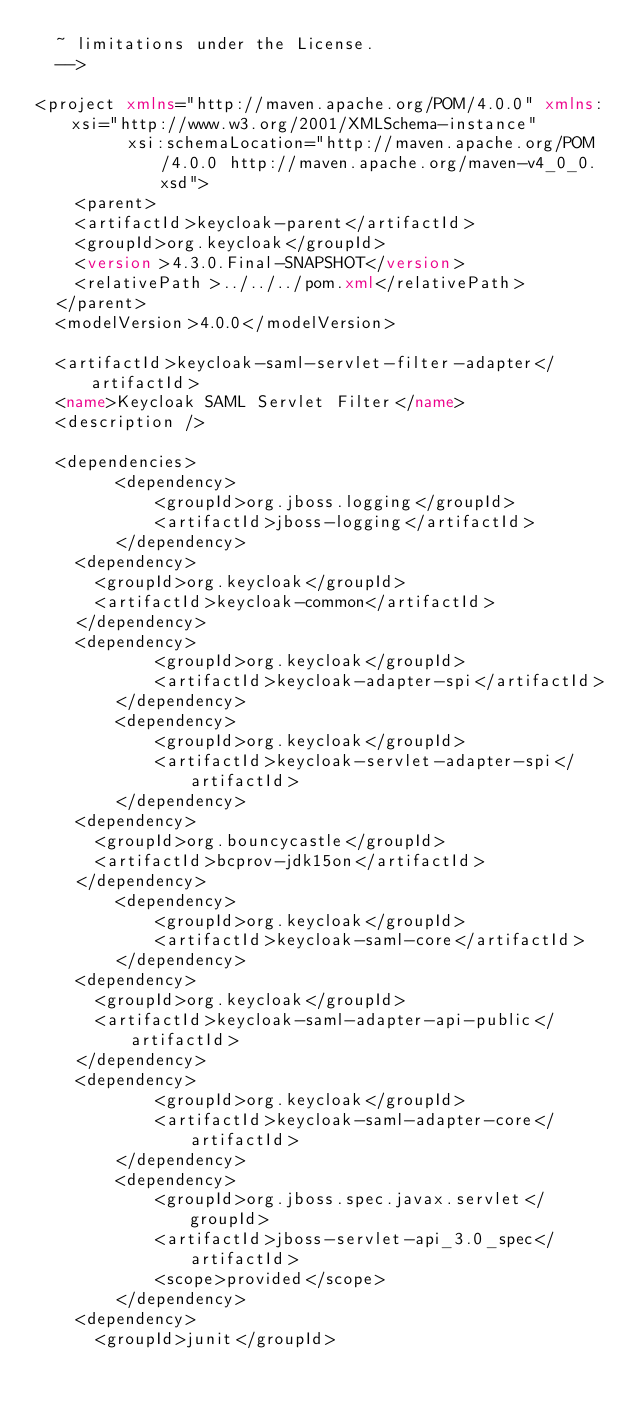Convert code to text. <code><loc_0><loc_0><loc_500><loc_500><_XML_>  ~ limitations under the License.
  -->

<project xmlns="http://maven.apache.org/POM/4.0.0" xmlns:xsi="http://www.w3.org/2001/XMLSchema-instance"
         xsi:schemaLocation="http://maven.apache.org/POM/4.0.0 http://maven.apache.org/maven-v4_0_0.xsd">
    <parent>
		<artifactId>keycloak-parent</artifactId>
		<groupId>org.keycloak</groupId>
		<version>4.3.0.Final-SNAPSHOT</version>
		<relativePath>../../../pom.xml</relativePath>
	</parent>
	<modelVersion>4.0.0</modelVersion>

	<artifactId>keycloak-saml-servlet-filter-adapter</artifactId>
	<name>Keycloak SAML Servlet Filter</name>
	<description />

	<dependencies>
        <dependency>
            <groupId>org.jboss.logging</groupId>
            <artifactId>jboss-logging</artifactId>
        </dependency>
		<dependency>
			<groupId>org.keycloak</groupId>
			<artifactId>keycloak-common</artifactId>
		</dependency>
		<dependency>
            <groupId>org.keycloak</groupId>
            <artifactId>keycloak-adapter-spi</artifactId>
        </dependency>
        <dependency>
            <groupId>org.keycloak</groupId>
            <artifactId>keycloak-servlet-adapter-spi</artifactId>
        </dependency>
		<dependency>
			<groupId>org.bouncycastle</groupId>
			<artifactId>bcprov-jdk15on</artifactId>
		</dependency>
        <dependency>
            <groupId>org.keycloak</groupId>
            <artifactId>keycloak-saml-core</artifactId>
        </dependency>
		<dependency>
			<groupId>org.keycloak</groupId>
			<artifactId>keycloak-saml-adapter-api-public</artifactId>
		</dependency>
		<dependency>
            <groupId>org.keycloak</groupId>
            <artifactId>keycloak-saml-adapter-core</artifactId>
        </dependency>
        <dependency>
            <groupId>org.jboss.spec.javax.servlet</groupId>
            <artifactId>jboss-servlet-api_3.0_spec</artifactId>
            <scope>provided</scope>
        </dependency>
		<dependency>
			<groupId>junit</groupId></code> 